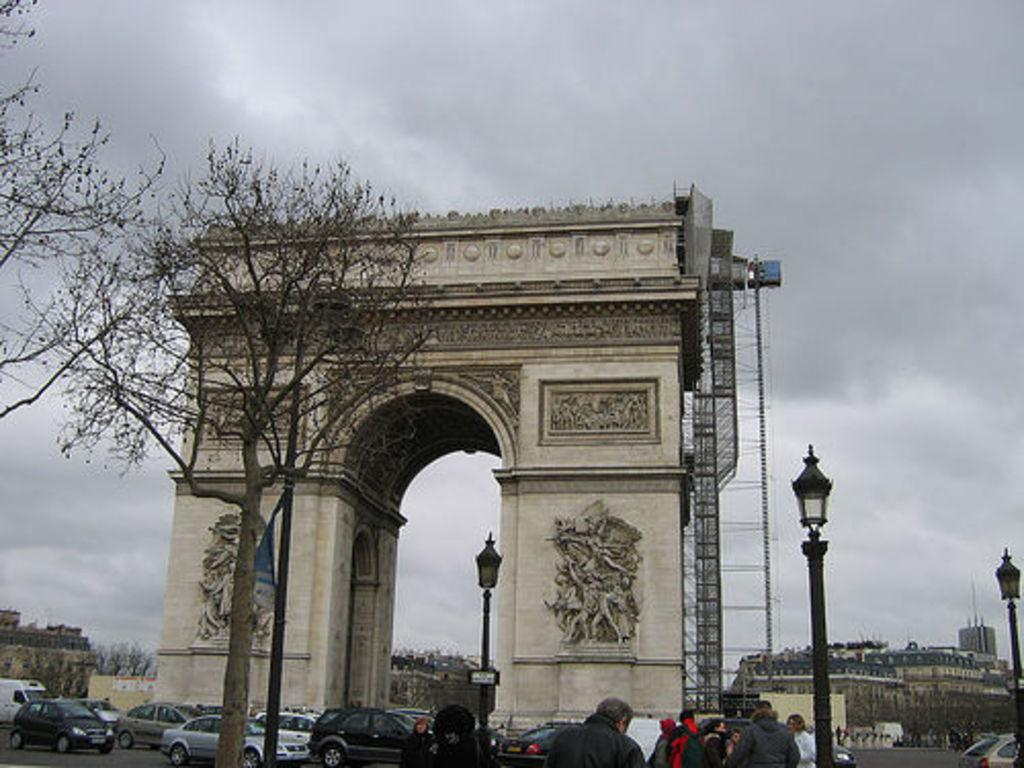Who or what can be seen in the image? There are people in the image. What else is visible on the road in the image? There are vehicles on the road in the image. What type of natural elements can be seen in the image? Trees are present in the image. What man-made structures are visible in the image? There are poles in the image. A: There are buildings in the image. How many police officers are present in the image? There is no mention of police officers in the image, so we cannot determine the amount. 